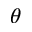<formula> <loc_0><loc_0><loc_500><loc_500>\theta</formula> 